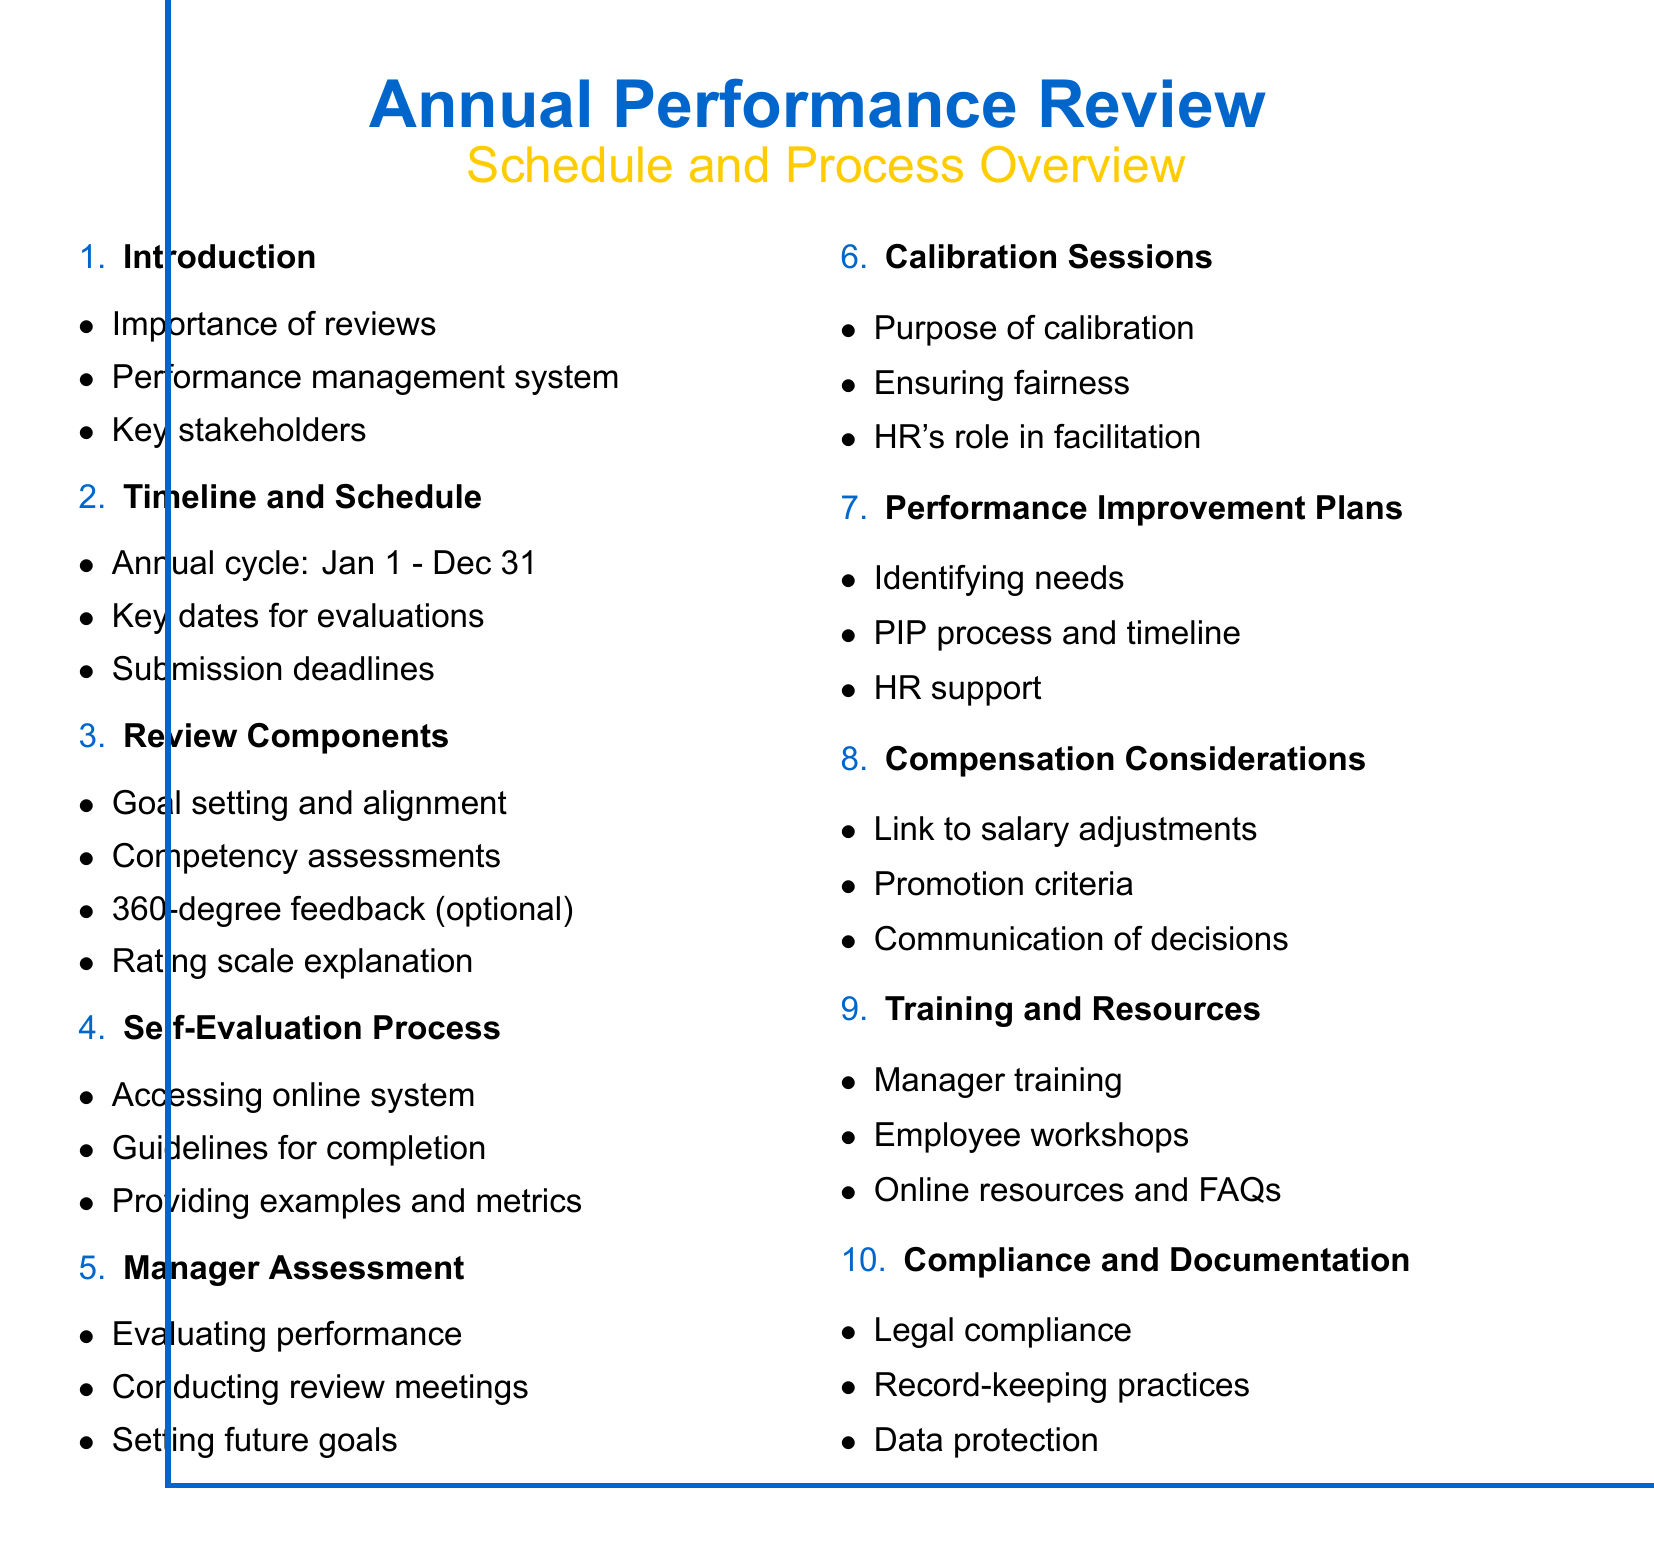What is the annual review cycle duration? The annual review cycle is mentioned to be from January 1 to December 31.
Answer: January 1 to December 31 Who are the key stakeholders in the performance review process? The document lists HR, managers, and employees as the key stakeholders.
Answer: HR, managers, and employees What does the performance rating scale range from? The performance rating scale is explained to range from 1 to 5.
Answer: 1-5 What is the purpose of calibration sessions? Calibration meetings are aimed at ensuring fairness and consistency across departments.
Answer: Ensuring fairness and consistency Which online performance management system is referenced for self-evaluation? The system specifically mentioned for accessing self-evaluations is Workday.
Answer: Workday What is one key component of the performance review? Goal setting and alignment with company objectives is listed as a key component.
Answer: Goal setting and alignment What do Performance Improvement Plans (PIPs) aim to address? PIPs are designed to identify employees who require additional support.
Answer: Identifying needs What type of training is offered for managers regarding performance reviews? Manager training on conducting effective performance reviews is offered.
Answer: Manager training What should be ensured regarding documentation in performance reviews? The document emphasizes ensuring legal compliance and proper record-keeping practices.
Answer: Legal compliance and proper record-keeping 